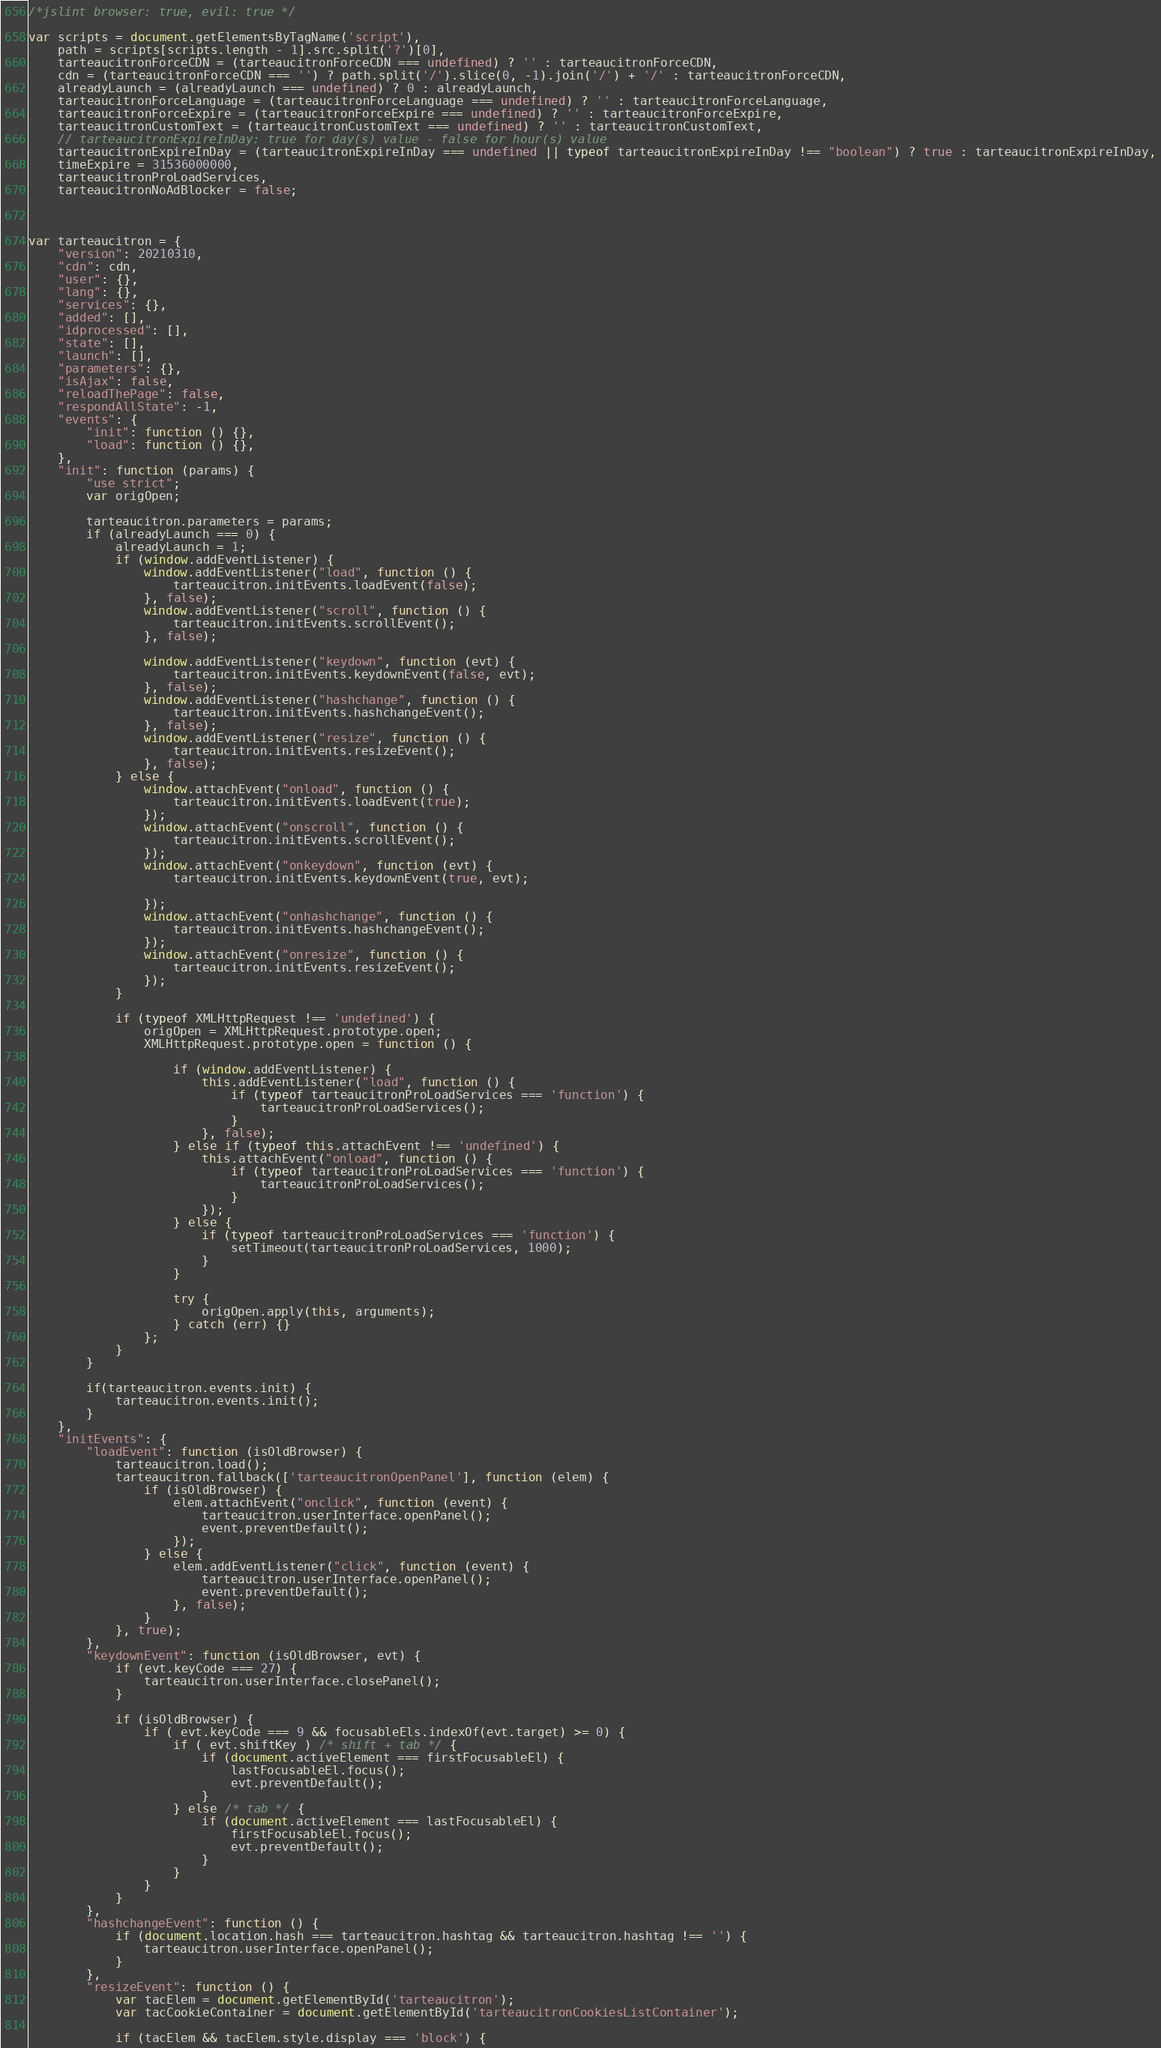<code> <loc_0><loc_0><loc_500><loc_500><_JavaScript_>/*jslint browser: true, evil: true */

var scripts = document.getElementsByTagName('script'),
    path = scripts[scripts.length - 1].src.split('?')[0],
    tarteaucitronForceCDN = (tarteaucitronForceCDN === undefined) ? '' : tarteaucitronForceCDN,
    cdn = (tarteaucitronForceCDN === '') ? path.split('/').slice(0, -1).join('/') + '/' : tarteaucitronForceCDN,
    alreadyLaunch = (alreadyLaunch === undefined) ? 0 : alreadyLaunch,
    tarteaucitronForceLanguage = (tarteaucitronForceLanguage === undefined) ? '' : tarteaucitronForceLanguage,
    tarteaucitronForceExpire = (tarteaucitronForceExpire === undefined) ? '' : tarteaucitronForceExpire,
    tarteaucitronCustomText = (tarteaucitronCustomText === undefined) ? '' : tarteaucitronCustomText,
    // tarteaucitronExpireInDay: true for day(s) value - false for hour(s) value
    tarteaucitronExpireInDay = (tarteaucitronExpireInDay === undefined || typeof tarteaucitronExpireInDay !== "boolean") ? true : tarteaucitronExpireInDay,
    timeExpire = 31536000000,
    tarteaucitronProLoadServices,
    tarteaucitronNoAdBlocker = false;



var tarteaucitron = {
    "version": 20210310,
    "cdn": cdn,
    "user": {},
    "lang": {},
    "services": {},
    "added": [],
    "idprocessed": [],
    "state": [],
    "launch": [],
    "parameters": {},
    "isAjax": false,
    "reloadThePage": false,
    "respondAllState": -1,
    "events": {
        "init": function () {},
        "load": function () {},
    },
    "init": function (params) {
        "use strict";
        var origOpen;

        tarteaucitron.parameters = params;
        if (alreadyLaunch === 0) {
            alreadyLaunch = 1;
            if (window.addEventListener) {
                window.addEventListener("load", function () {
                    tarteaucitron.initEvents.loadEvent(false);
                }, false);
                window.addEventListener("scroll", function () {
                    tarteaucitron.initEvents.scrollEvent();
                }, false);

                window.addEventListener("keydown", function (evt) {
                    tarteaucitron.initEvents.keydownEvent(false, evt);
                }, false);
                window.addEventListener("hashchange", function () {
                    tarteaucitron.initEvents.hashchangeEvent();
                }, false);
                window.addEventListener("resize", function () {
                    tarteaucitron.initEvents.resizeEvent();
                }, false);
            } else {
                window.attachEvent("onload", function () {
                    tarteaucitron.initEvents.loadEvent(true);
                });
                window.attachEvent("onscroll", function () {
                    tarteaucitron.initEvents.scrollEvent();
                });
                window.attachEvent("onkeydown", function (evt) {
                    tarteaucitron.initEvents.keydownEvent(true, evt);

                });
                window.attachEvent("onhashchange", function () {
                    tarteaucitron.initEvents.hashchangeEvent();
                });
                window.attachEvent("onresize", function () {
                    tarteaucitron.initEvents.resizeEvent();
                });
            }

            if (typeof XMLHttpRequest !== 'undefined') {
                origOpen = XMLHttpRequest.prototype.open;
                XMLHttpRequest.prototype.open = function () {

                    if (window.addEventListener) {
                        this.addEventListener("load", function () {
                            if (typeof tarteaucitronProLoadServices === 'function') {
                                tarteaucitronProLoadServices();
                            }
                        }, false);
                    } else if (typeof this.attachEvent !== 'undefined') {
                        this.attachEvent("onload", function () {
                            if (typeof tarteaucitronProLoadServices === 'function') {
                                tarteaucitronProLoadServices();
                            }
                        });
                    } else {
                        if (typeof tarteaucitronProLoadServices === 'function') {
                            setTimeout(tarteaucitronProLoadServices, 1000);
                        }
                    }

                    try {
                        origOpen.apply(this, arguments);
                    } catch (err) {}
                };
            }
        }

        if(tarteaucitron.events.init) {
            tarteaucitron.events.init();
        }
    },
    "initEvents": {
        "loadEvent": function (isOldBrowser) {
            tarteaucitron.load();
            tarteaucitron.fallback(['tarteaucitronOpenPanel'], function (elem) {
                if (isOldBrowser) {
                    elem.attachEvent("onclick", function (event) {
                        tarteaucitron.userInterface.openPanel();
                        event.preventDefault();
                    });
                } else {
                    elem.addEventListener("click", function (event) {
                        tarteaucitron.userInterface.openPanel();
                        event.preventDefault();
                    }, false);
                }
            }, true);
        },
        "keydownEvent": function (isOldBrowser, evt) {
            if (evt.keyCode === 27) {
                tarteaucitron.userInterface.closePanel();
            }

            if (isOldBrowser) {
                if ( evt.keyCode === 9 && focusableEls.indexOf(evt.target) >= 0) {
                    if ( evt.shiftKey ) /* shift + tab */ {
                        if (document.activeElement === firstFocusableEl) {
                            lastFocusableEl.focus();
                            evt.preventDefault();
                        }
                    } else /* tab */ {
                        if (document.activeElement === lastFocusableEl) {
                            firstFocusableEl.focus();
                            evt.preventDefault();
                        }
                    }
                }
            }
        },
        "hashchangeEvent": function () {
            if (document.location.hash === tarteaucitron.hashtag && tarteaucitron.hashtag !== '') {
                tarteaucitron.userInterface.openPanel();
            }
        },
        "resizeEvent": function () {
            var tacElem = document.getElementById('tarteaucitron');
            var tacCookieContainer = document.getElementById('tarteaucitronCookiesListContainer');

            if (tacElem && tacElem.style.display === 'block') {</code> 